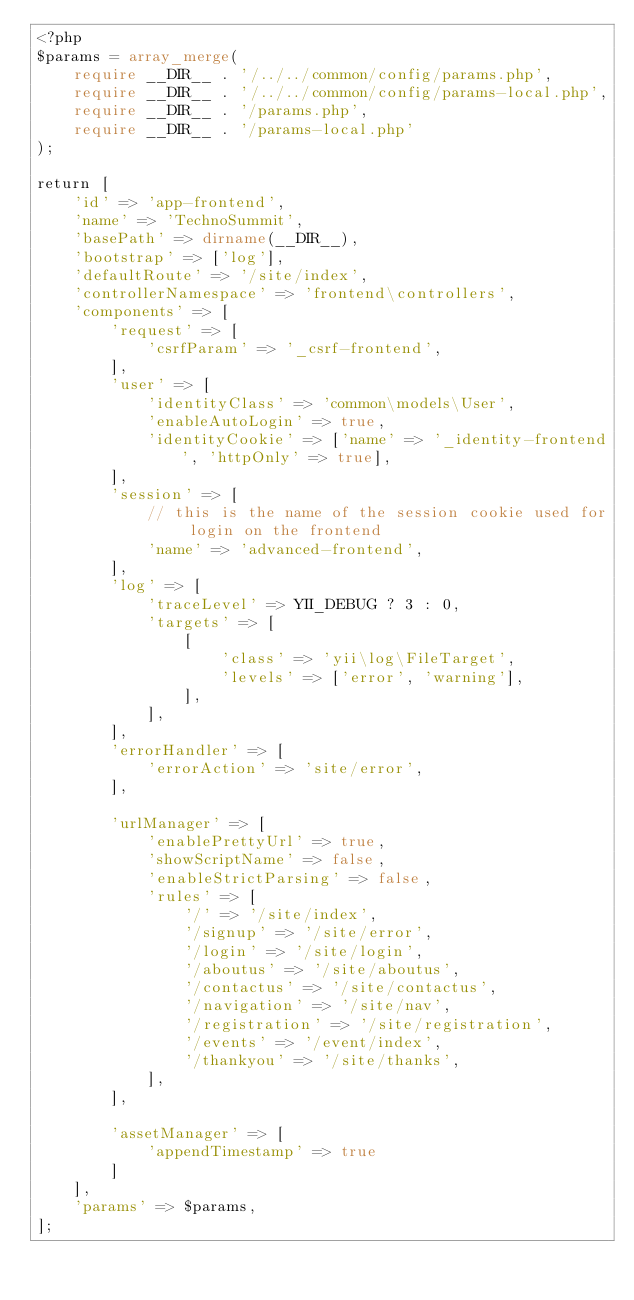Convert code to text. <code><loc_0><loc_0><loc_500><loc_500><_PHP_><?php
$params = array_merge(
    require __DIR__ . '/../../common/config/params.php',
    require __DIR__ . '/../../common/config/params-local.php',
    require __DIR__ . '/params.php',
    require __DIR__ . '/params-local.php'
);

return [
    'id' => 'app-frontend',
    'name' => 'TechnoSummit',
    'basePath' => dirname(__DIR__),
    'bootstrap' => ['log'],
    'defaultRoute' => '/site/index',
    'controllerNamespace' => 'frontend\controllers',
    'components' => [
        'request' => [
            'csrfParam' => '_csrf-frontend',
        ],
        'user' => [
            'identityClass' => 'common\models\User',
            'enableAutoLogin' => true,
            'identityCookie' => ['name' => '_identity-frontend', 'httpOnly' => true],
        ],
        'session' => [
            // this is the name of the session cookie used for login on the frontend
            'name' => 'advanced-frontend',
        ],
        'log' => [
            'traceLevel' => YII_DEBUG ? 3 : 0,
            'targets' => [
                [
                    'class' => 'yii\log\FileTarget',
                    'levels' => ['error', 'warning'],
                ],
            ],
        ],
        'errorHandler' => [
            'errorAction' => 'site/error',
        ],

        'urlManager' => [
            'enablePrettyUrl' => true,
            'showScriptName' => false,
            'enableStrictParsing' => false,
            'rules' => [
                '/' => '/site/index',
                '/signup' => '/site/error',
                '/login' => '/site/login',
                '/aboutus' => '/site/aboutus',
                '/contactus' => '/site/contactus',
                '/navigation' => '/site/nav',
                '/registration' => '/site/registration',
                '/events' => '/event/index',
                '/thankyou' => '/site/thanks',
            ],
        ],

        'assetManager' => [
            'appendTimestamp' => true
        ]
    ],
    'params' => $params,
];
</code> 